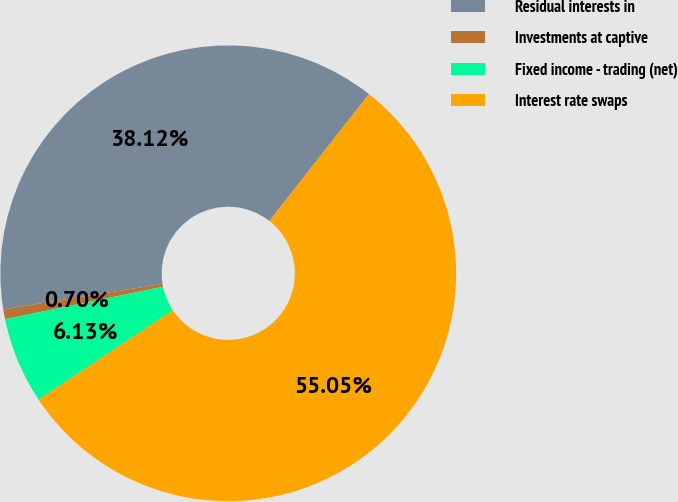Convert chart. <chart><loc_0><loc_0><loc_500><loc_500><pie_chart><fcel>Residual interests in<fcel>Investments at captive<fcel>Fixed income - trading (net)<fcel>Interest rate swaps<nl><fcel>38.12%<fcel>0.7%<fcel>6.13%<fcel>55.05%<nl></chart> 